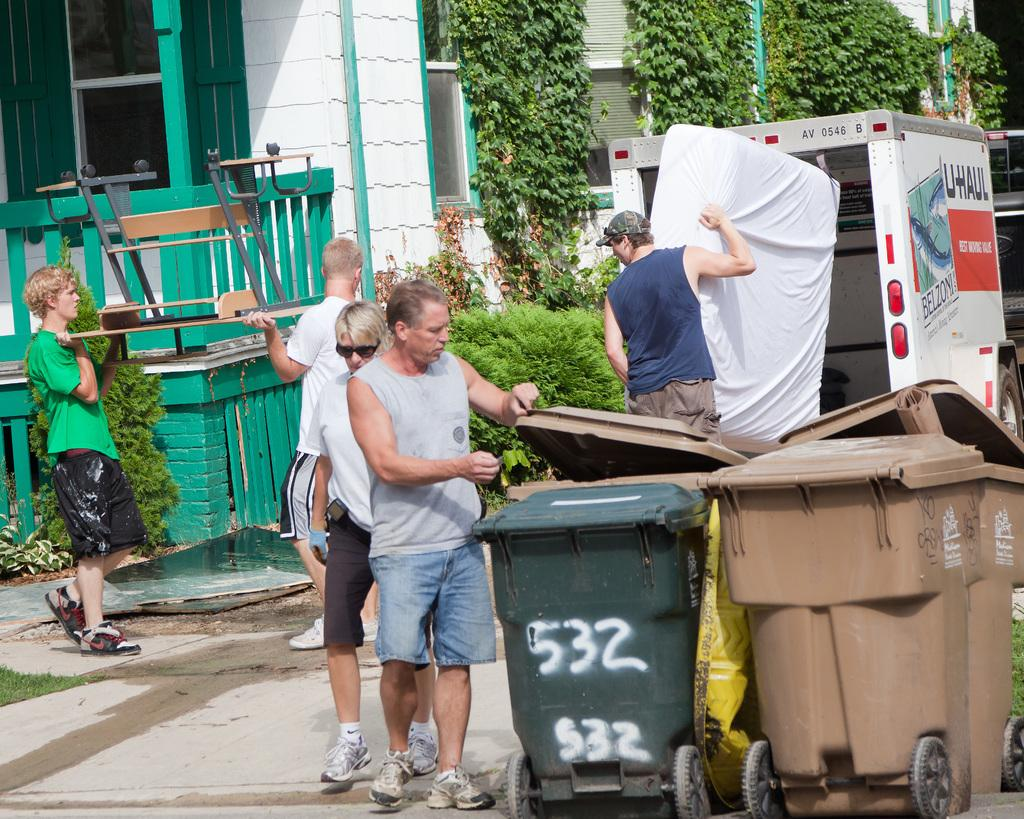<image>
Present a compact description of the photo's key features. The white and orange trailer is from Uhaul 